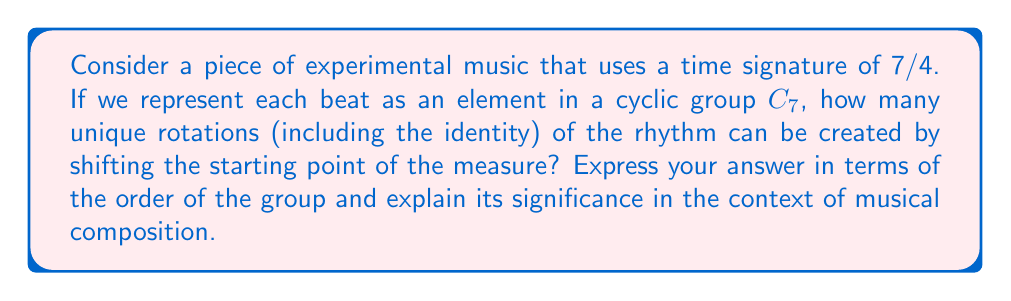Teach me how to tackle this problem. To solve this problem, we need to understand the properties of cyclic groups and how they relate to time signatures in music:

1) In a 7/4 time signature, there are 7 beats in each measure. We can represent this as a cyclic group $C_7$ with 7 elements.

2) In group theory, the number of unique rotations of a cyclic group is equal to the order of the group. The order of a group is the number of elements in the group.

3) For $C_7$, the order is 7. This means there are 7 unique rotations, including the identity rotation (no shift).

4) Mathematically, we can represent these rotations as:

   $$r^0, r^1, r^2, r^3, r^4, r^5, r^6$$

   where $r$ represents a single rotation and the exponent represents the number of positions shifted.

5) In musical terms, each of these rotations represents a different starting point for the measure. For example:
   - $r^0$: 1 2 3 4 5 6 7
   - $r^1$: 2 3 4 5 6 7 1
   - $r^2$: 3 4 5 6 7 1 2
   and so on...

6) This property is significant in experimental music composition as it allows for the creation of complex polyrhythms and the exploration of different metric feels while maintaining the overall structure of the 7/4 time signature.

7) The number of unique rotations being equal to the order of the group (7 in this case) ensures that all possible starting points are covered before the pattern repeats.
Answer: The number of unique rotations is 7, which is equal to the order of the cyclic group $C_7$. This property allows composers to explore 7 distinct rhythmic variations of the same 7/4 measure, contributing to the complexity and experimental nature of the composition. 